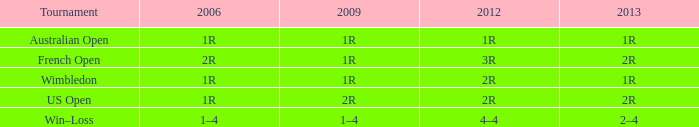What is the Tournament when the 2013 is 1r? Australian Open, Wimbledon. 